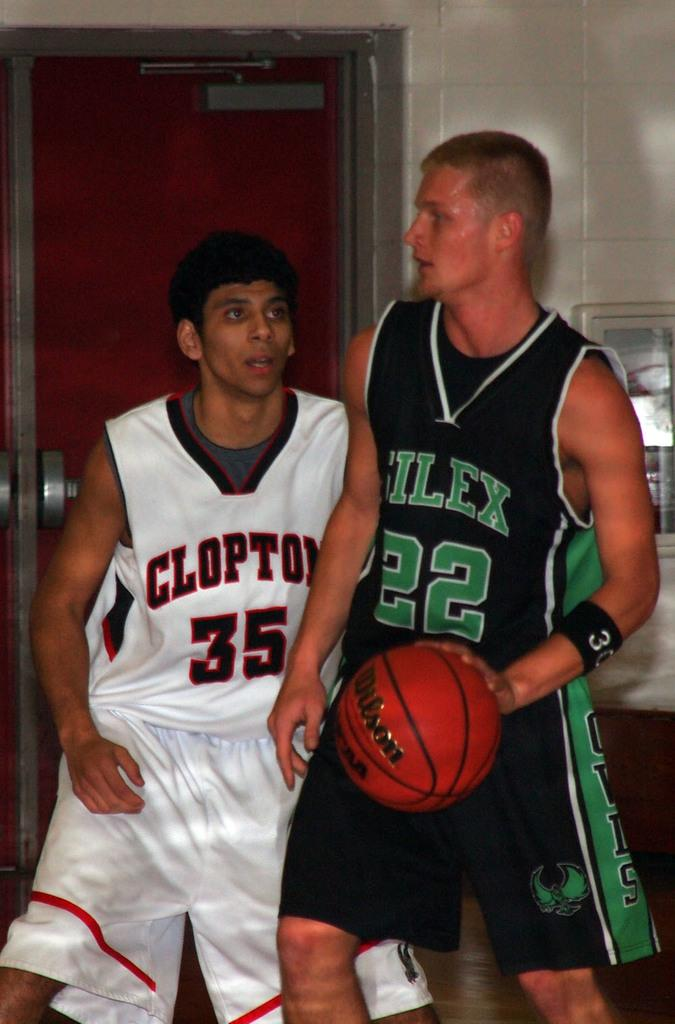<image>
Give a short and clear explanation of the subsequent image. Player 35 is on the team playing against the player 22. 